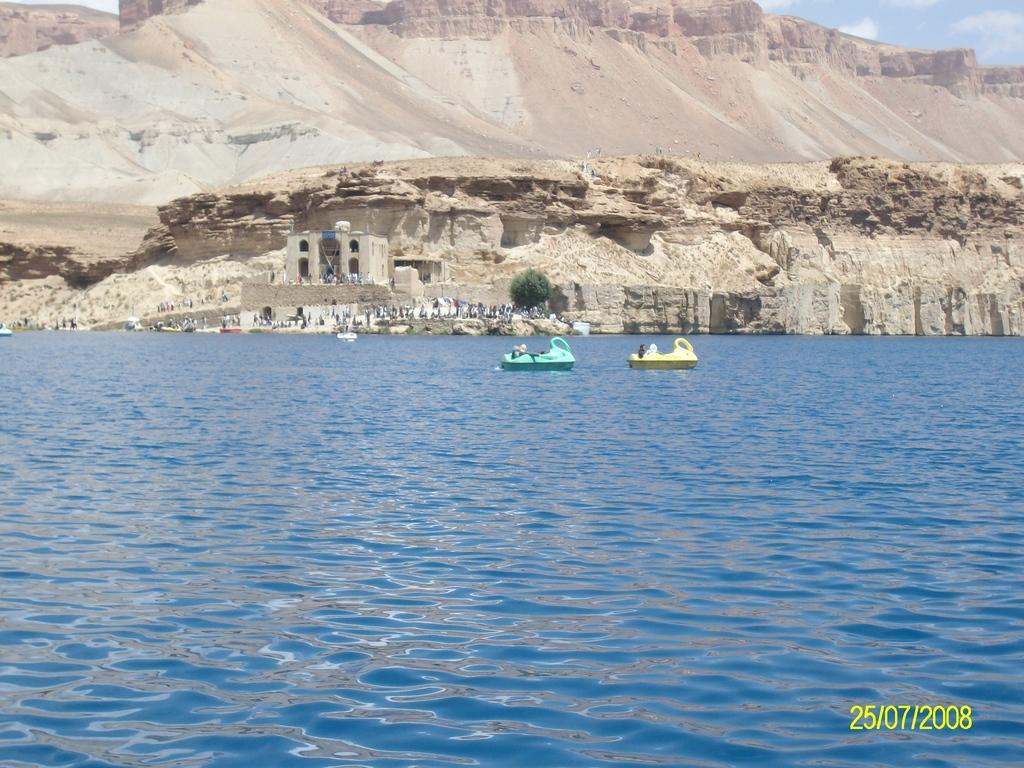What is happening in the water in the image? There are boats sailing in the water. What are the people on the ground doing? The people standing on the ground are not engaged in any specific activity in the image. What type of structure can be seen in the image? There is a building visible in the image. Where is the building located in relation to the stone hill? The building is located under a stone hill. What type of discovery was made by the people standing on the ground in the image? There is no indication of a discovery being made in the image; the people are simply standing on the ground. How much was the payment for the boats sailing in the water in the image? There is no information about any payment in the image; it only shows boats sailing in the water. 